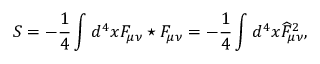<formula> <loc_0><loc_0><loc_500><loc_500>S = - \frac { 1 } { 4 } \int d ^ { 4 } x F _ { \mu \nu } ^ { * } F _ { \mu \nu } = - \frac { 1 } { 4 } \int d ^ { 4 } x \widehat { F } _ { \mu \nu } ^ { 2 } ,</formula> 